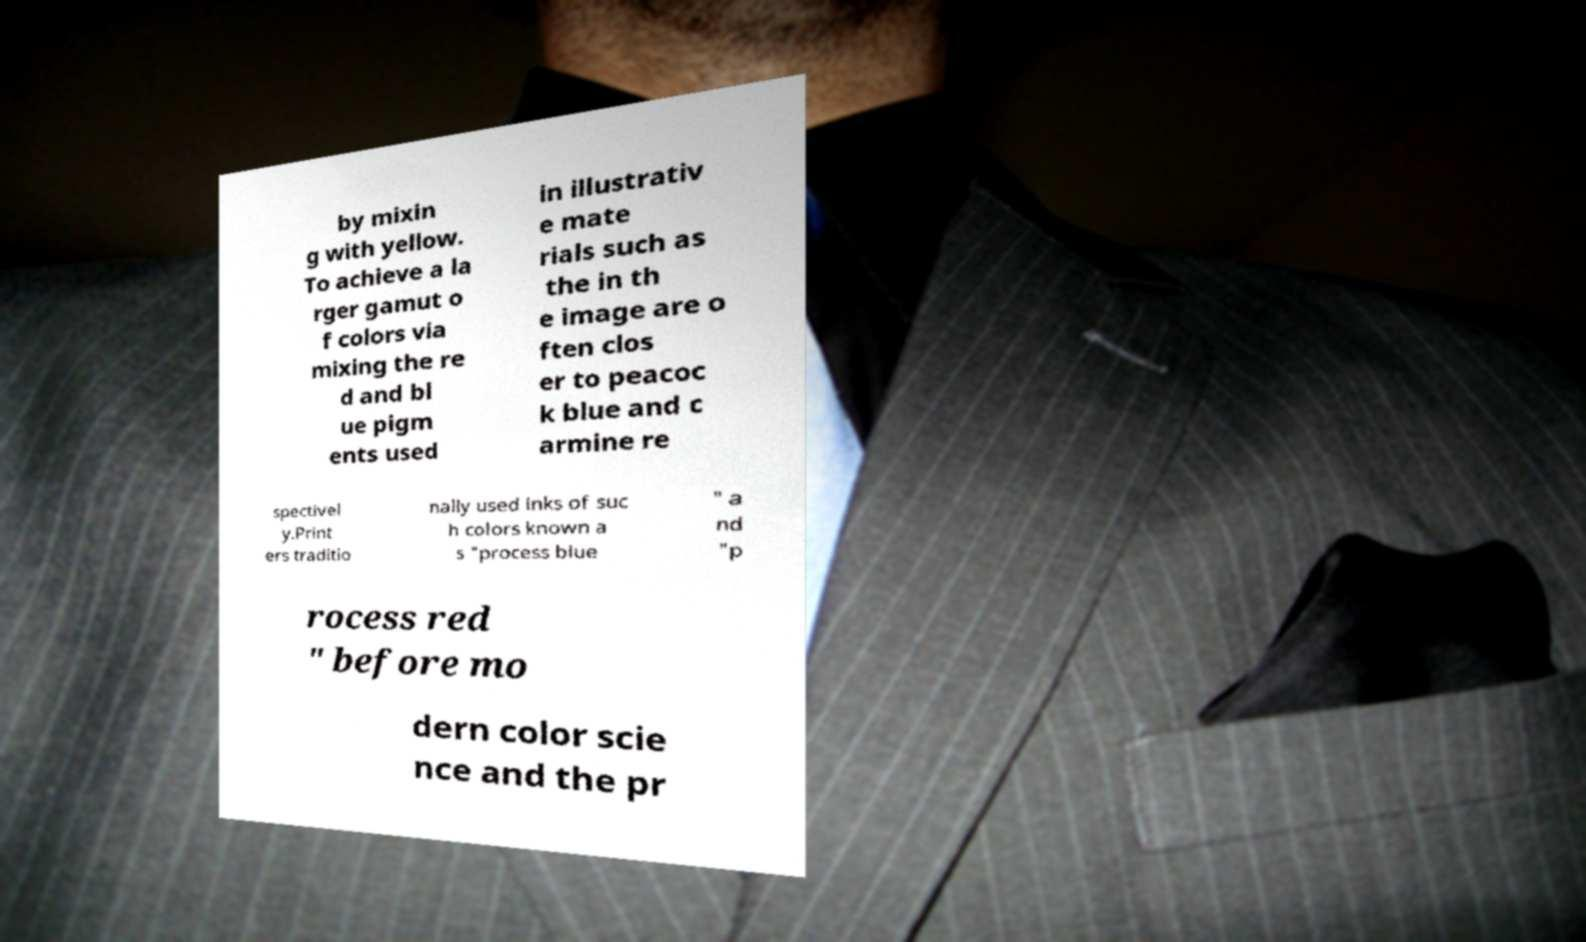Please read and relay the text visible in this image. What does it say? by mixin g with yellow. To achieve a la rger gamut o f colors via mixing the re d and bl ue pigm ents used in illustrativ e mate rials such as the in th e image are o ften clos er to peacoc k blue and c armine re spectivel y.Print ers traditio nally used inks of suc h colors known a s "process blue " a nd "p rocess red " before mo dern color scie nce and the pr 